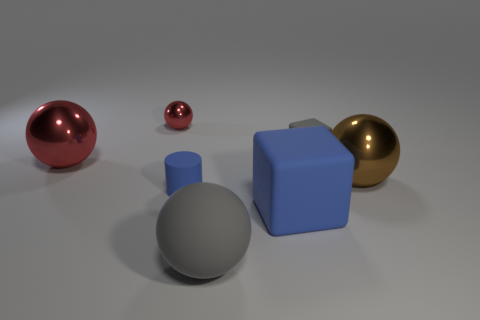Subtract all big balls. How many balls are left? 1 Subtract 0 cyan balls. How many objects are left? 7 Subtract all balls. How many objects are left? 3 Subtract 2 balls. How many balls are left? 2 Subtract all yellow blocks. Subtract all green balls. How many blocks are left? 2 Subtract all cyan cubes. How many red cylinders are left? 0 Subtract all purple matte cubes. Subtract all gray spheres. How many objects are left? 6 Add 6 matte blocks. How many matte blocks are left? 8 Add 4 cylinders. How many cylinders exist? 5 Add 3 large yellow metallic things. How many objects exist? 10 